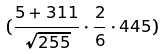Convert formula to latex. <formula><loc_0><loc_0><loc_500><loc_500>( \frac { 5 + 3 1 1 } { \sqrt { 2 5 5 } } \cdot \frac { 2 } { 6 } \cdot 4 4 5 )</formula> 